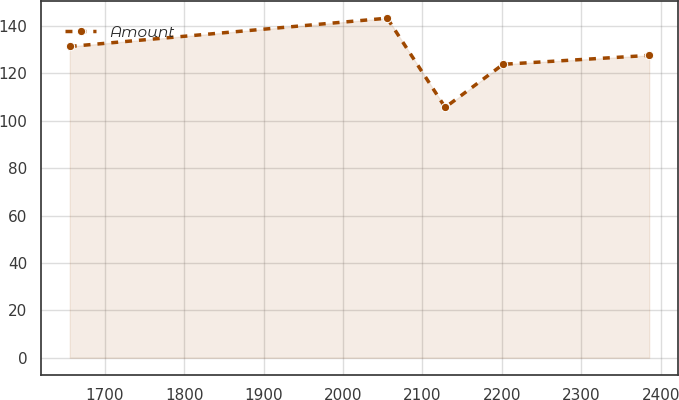<chart> <loc_0><loc_0><loc_500><loc_500><line_chart><ecel><fcel>Amount<nl><fcel>1655.89<fcel>131.39<nl><fcel>2055.69<fcel>143.33<nl><fcel>2128.66<fcel>105.69<nl><fcel>2201.63<fcel>123.87<nl><fcel>2385.58<fcel>127.63<nl></chart> 